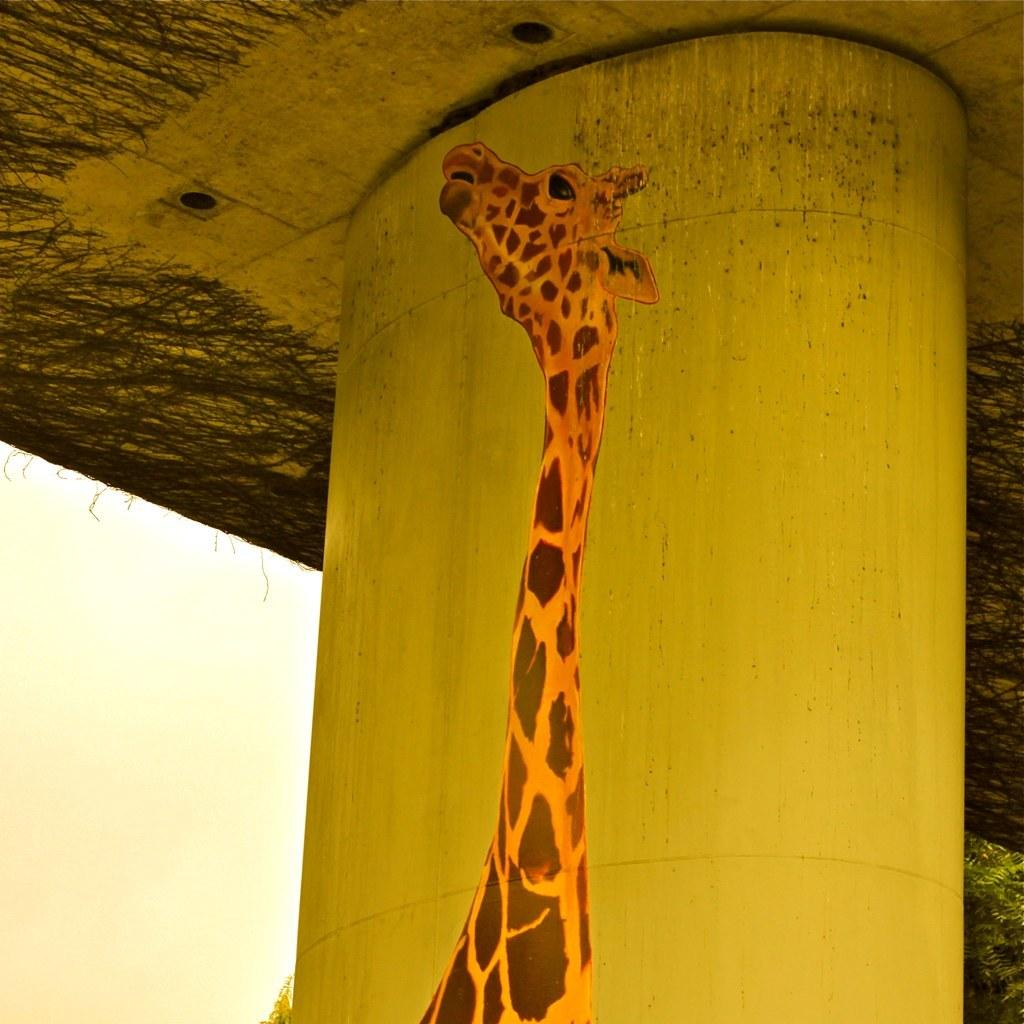What is depicted on the pillar in the image? There is a giraffe painting on a pillar in the image. What structure is visible above the giraffe painting? There is a bridge above the giraffe painting in the image. What type of summer show is taking place near the giraffe painting in the image? There is no indication of a summer show or any event taking place near the giraffe painting in the image. 